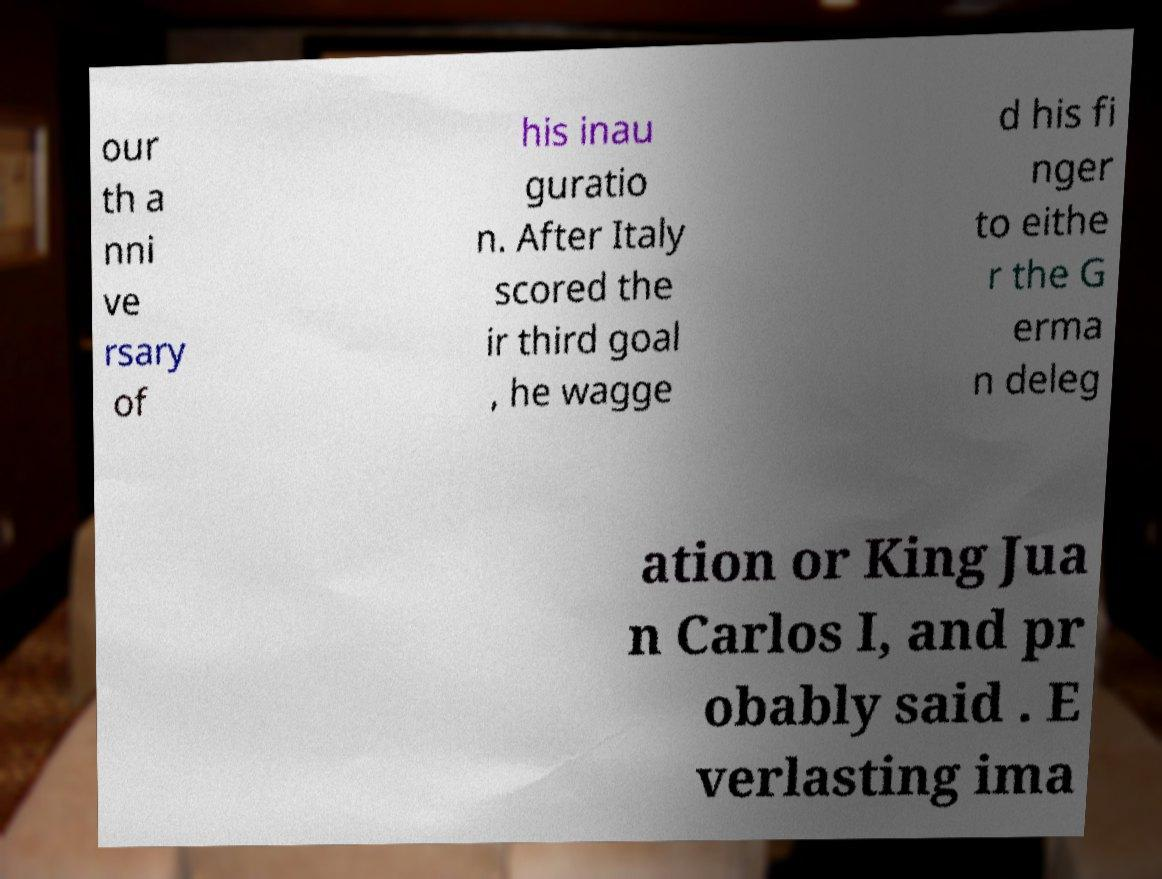Please identify and transcribe the text found in this image. our th a nni ve rsary of his inau guratio n. After Italy scored the ir third goal , he wagge d his fi nger to eithe r the G erma n deleg ation or King Jua n Carlos I, and pr obably said . E verlasting ima 